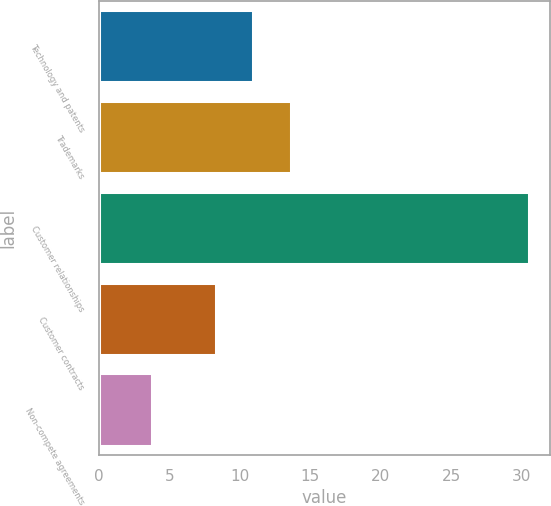Convert chart to OTSL. <chart><loc_0><loc_0><loc_500><loc_500><bar_chart><fcel>Technology and patents<fcel>Trademarks<fcel>Customer relationships<fcel>Customer contracts<fcel>Non-compete agreements<nl><fcel>10.97<fcel>13.64<fcel>30.5<fcel>8.3<fcel>3.8<nl></chart> 